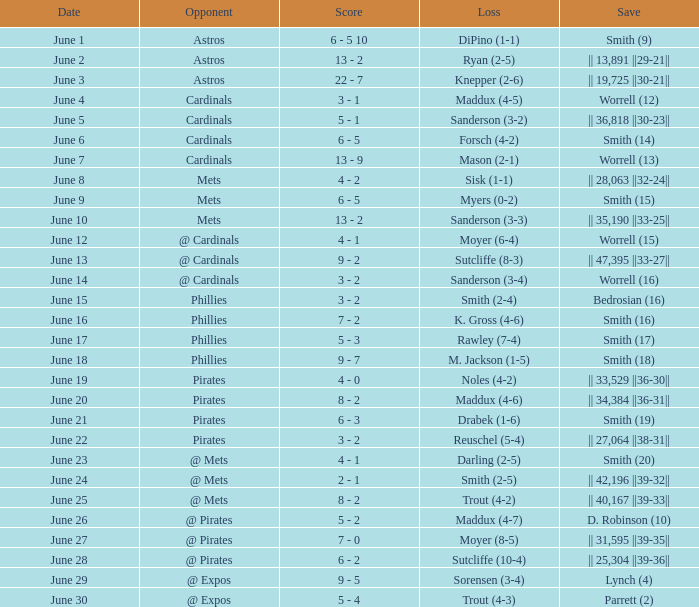On which day did the Chicago Cubs have a loss of trout (4-2)? June 25. 